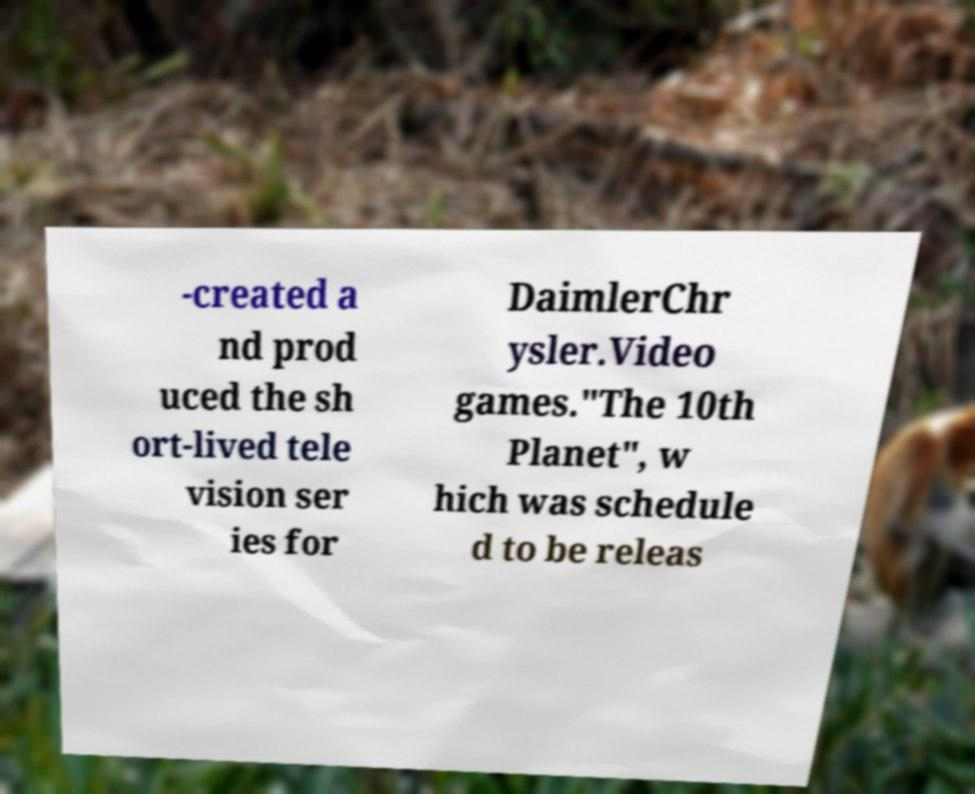Please identify and transcribe the text found in this image. -created a nd prod uced the sh ort-lived tele vision ser ies for DaimlerChr ysler.Video games."The 10th Planet", w hich was schedule d to be releas 